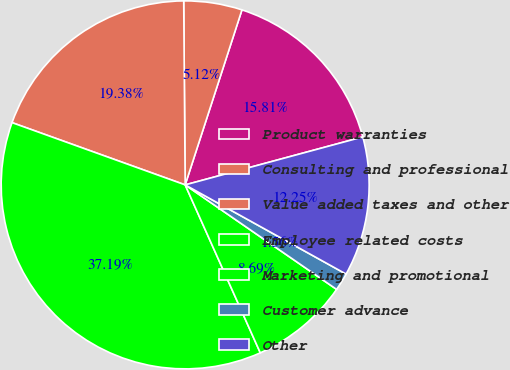<chart> <loc_0><loc_0><loc_500><loc_500><pie_chart><fcel>Product warranties<fcel>Consulting and professional<fcel>Value added taxes and other<fcel>Employee related costs<fcel>Marketing and promotional<fcel>Customer advance<fcel>Other<nl><fcel>15.81%<fcel>5.12%<fcel>19.38%<fcel>37.19%<fcel>8.69%<fcel>1.56%<fcel>12.25%<nl></chart> 